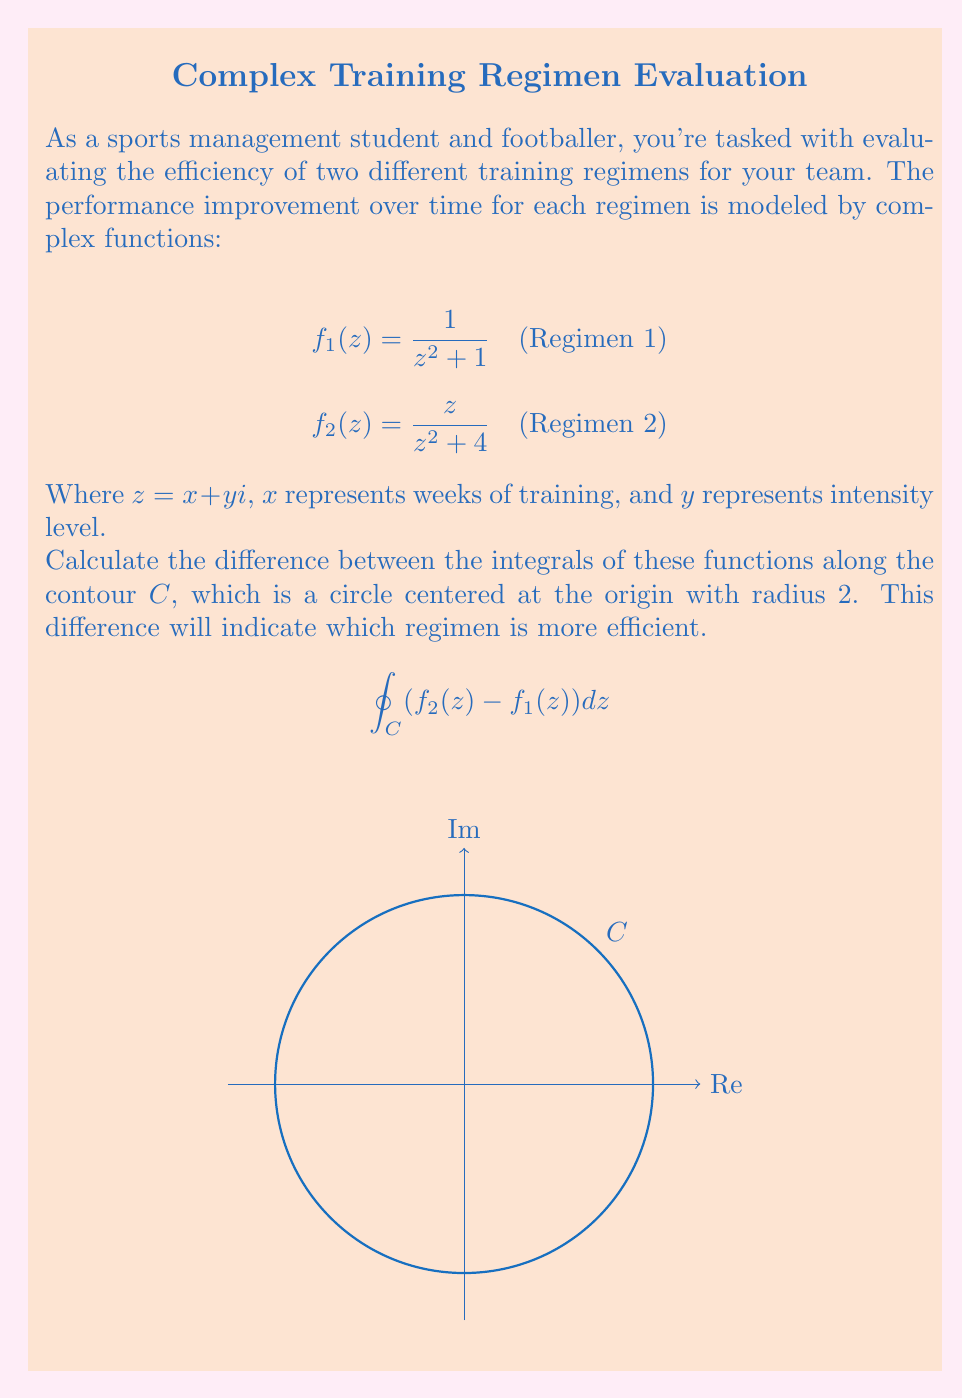Give your solution to this math problem. Let's approach this step-by-step:

1) We need to evaluate $\oint_C (f_2(z) - f_1(z)) dz$, where $C$ is the circle $|z| = 2$.

2) First, let's consider $f_1(z) = \frac{1}{z^2 + 1}$. This function has poles at $z = \pm i$, which are both inside the contour $C$.

3) For $f_2(z) = \frac{z}{z^2 + 4}$, the poles are at $z = \pm 2i$, which are outside the contour $C$.

4) We can use the residue theorem: $\oint_C f(z)dz = 2\pi i \sum \text{Res}(f, a_k)$, where $a_k$ are the poles inside $C$.

5) For $f_1(z)$:
   Res$(f_1, i) = \lim_{z \to i} (z-i)\frac{1}{z^2+1} = \frac{1}{2i}$
   Res$(f_1, -i) = \lim_{z \to -i} (z+i)\frac{1}{z^2+1} = -\frac{1}{2i}$

6) Therefore, $\oint_C f_1(z)dz = 2\pi i (\frac{1}{2i} - \frac{1}{2i}) = 0$

7) For $f_2(z)$, there are no poles inside $C$, so $\oint_C f_2(z)dz = 0$

8) Thus, $\oint_C (f_2(z) - f_1(z)) dz = 0 - 0 = 0$

This result indicates that both training regimens are equally efficient over the given time and intensity range.
Answer: $0$ 